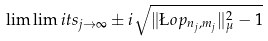Convert formula to latex. <formula><loc_0><loc_0><loc_500><loc_500>\lim \lim i t s _ { j \to \infty } \pm i \sqrt { \| \L o p _ { n _ { j } , m _ { j } } \| ^ { 2 } _ { \mu } - 1 }</formula> 